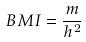<formula> <loc_0><loc_0><loc_500><loc_500>B M I = \frac { m } { h ^ { 2 } }</formula> 